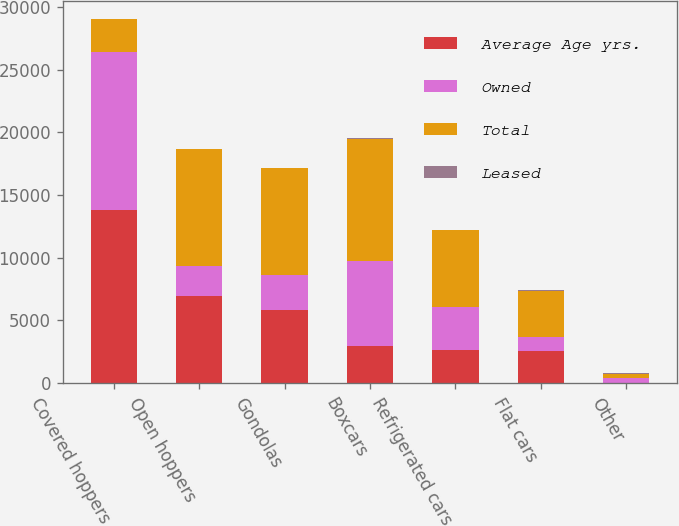Convert chart to OTSL. <chart><loc_0><loc_0><loc_500><loc_500><stacked_bar_chart><ecel><fcel>Covered hoppers<fcel>Open hoppers<fcel>Gondolas<fcel>Boxcars<fcel>Refrigerated cars<fcel>Flat cars<fcel>Other<nl><fcel>Average Age yrs.<fcel>13804<fcel>6897<fcel>5798<fcel>2957<fcel>2600<fcel>2533<fcel>8<nl><fcel>Owned<fcel>12629<fcel>2427<fcel>2772<fcel>6780<fcel>3486<fcel>1147<fcel>353<nl><fcel>Total<fcel>2600<fcel>9324<fcel>8570<fcel>9737<fcel>6086<fcel>3680<fcel>361<nl><fcel>Leased<fcel>20.4<fcel>30.9<fcel>26.7<fcel>36.1<fcel>25.4<fcel>32.4<fcel>29.9<nl></chart> 